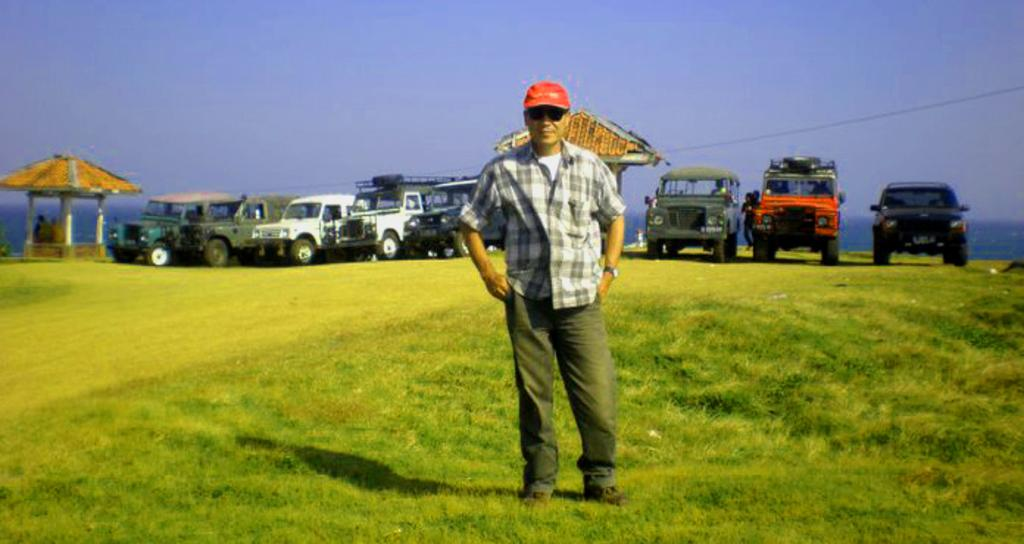What is the main subject of the image? There is a man in the image. What is the man wearing on his head? The man is wearing a cap. What is the man wearing to protect his eyes? The man is wearing goggles. Where is the man standing in the image? The man is standing on the ground. What else can be seen in the image besides the man? There are vehicles and sheds in the image. What is visible in the background of the image? The sky is visible in the background of the image. What type of teeth can be seen in the image? There are no teeth visible in the image. What is the man attempting to do in the image? The image does not provide any information about what the man is attempting to do. 